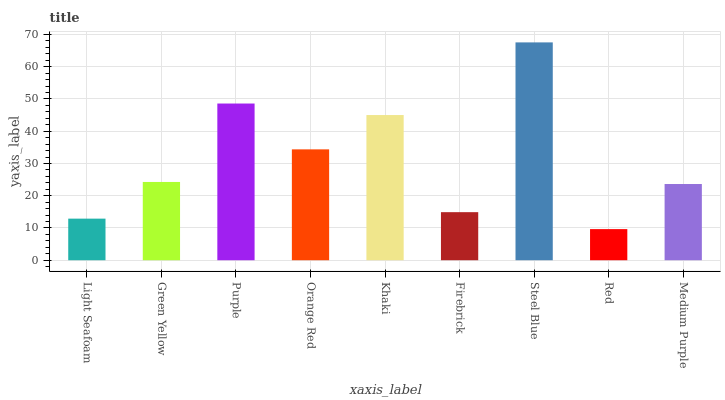Is Red the minimum?
Answer yes or no. Yes. Is Steel Blue the maximum?
Answer yes or no. Yes. Is Green Yellow the minimum?
Answer yes or no. No. Is Green Yellow the maximum?
Answer yes or no. No. Is Green Yellow greater than Light Seafoam?
Answer yes or no. Yes. Is Light Seafoam less than Green Yellow?
Answer yes or no. Yes. Is Light Seafoam greater than Green Yellow?
Answer yes or no. No. Is Green Yellow less than Light Seafoam?
Answer yes or no. No. Is Green Yellow the high median?
Answer yes or no. Yes. Is Green Yellow the low median?
Answer yes or no. Yes. Is Khaki the high median?
Answer yes or no. No. Is Orange Red the low median?
Answer yes or no. No. 